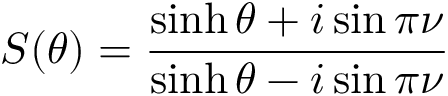Convert formula to latex. <formula><loc_0><loc_0><loc_500><loc_500>S ( \theta ) = \frac { \sinh \theta + i \sin \pi \nu } { \sinh \theta - i \sin \pi \nu }</formula> 